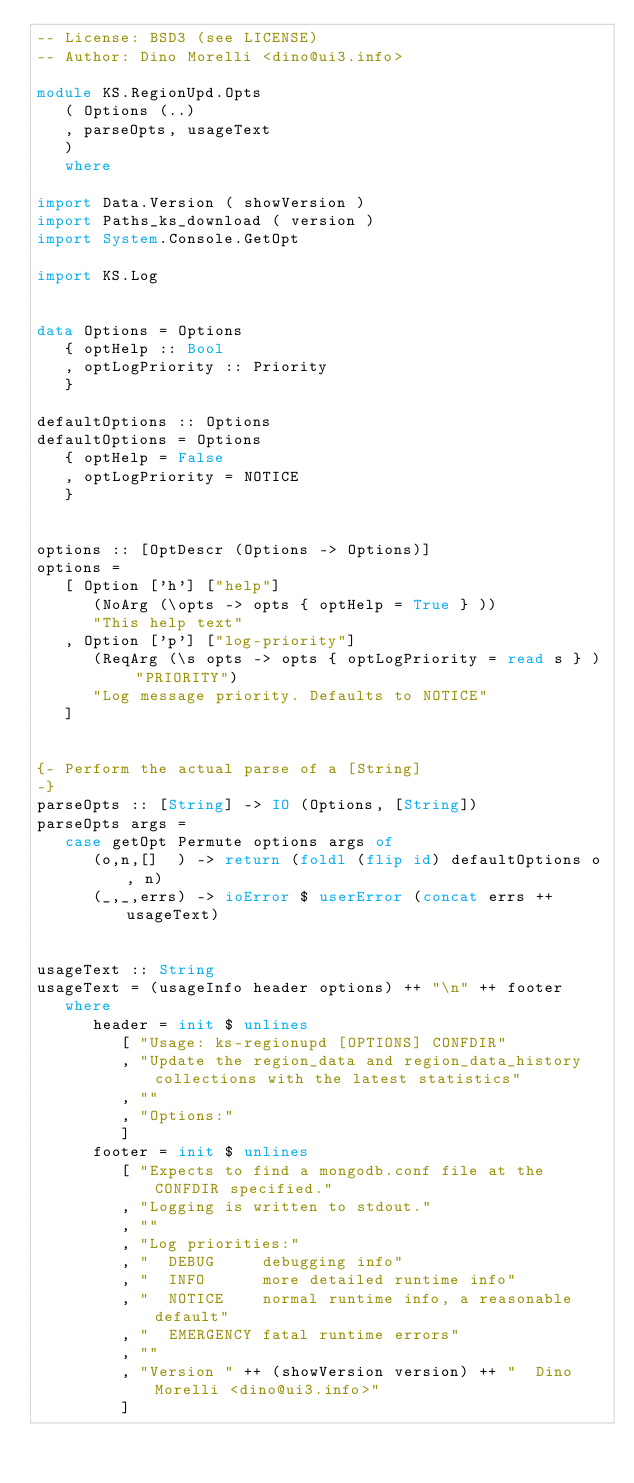<code> <loc_0><loc_0><loc_500><loc_500><_Haskell_>-- License: BSD3 (see LICENSE)
-- Author: Dino Morelli <dino@ui3.info>

module KS.RegionUpd.Opts
   ( Options (..)
   , parseOpts, usageText
   )
   where

import Data.Version ( showVersion )
import Paths_ks_download ( version )
import System.Console.GetOpt

import KS.Log


data Options = Options
   { optHelp :: Bool
   , optLogPriority :: Priority
   }

defaultOptions :: Options
defaultOptions = Options
   { optHelp = False
   , optLogPriority = NOTICE
   }


options :: [OptDescr (Options -> Options)]
options =
   [ Option ['h'] ["help"]
      (NoArg (\opts -> opts { optHelp = True } ))
      "This help text"
   , Option ['p'] ["log-priority"]
      (ReqArg (\s opts -> opts { optLogPriority = read s } ) "PRIORITY")
      "Log message priority. Defaults to NOTICE"
   ]


{- Perform the actual parse of a [String]
-}
parseOpts :: [String] -> IO (Options, [String])
parseOpts args =
   case getOpt Permute options args of
      (o,n,[]  ) -> return (foldl (flip id) defaultOptions o, n)
      (_,_,errs) -> ioError $ userError (concat errs ++ usageText)


usageText :: String
usageText = (usageInfo header options) ++ "\n" ++ footer
   where
      header = init $ unlines
         [ "Usage: ks-regionupd [OPTIONS] CONFDIR"
         , "Update the region_data and region_data_history collections with the latest statistics"
         , ""
         , "Options:"
         ]
      footer = init $ unlines
         [ "Expects to find a mongodb.conf file at the CONFDIR specified."
         , "Logging is written to stdout."
         , ""
         , "Log priorities:"
         , "  DEBUG     debugging info"
         , "  INFO      more detailed runtime info"
         , "  NOTICE    normal runtime info, a reasonable default"
         , "  EMERGENCY fatal runtime errors"
         , ""
         , "Version " ++ (showVersion version) ++ "  Dino Morelli <dino@ui3.info>"
         ]
</code> 